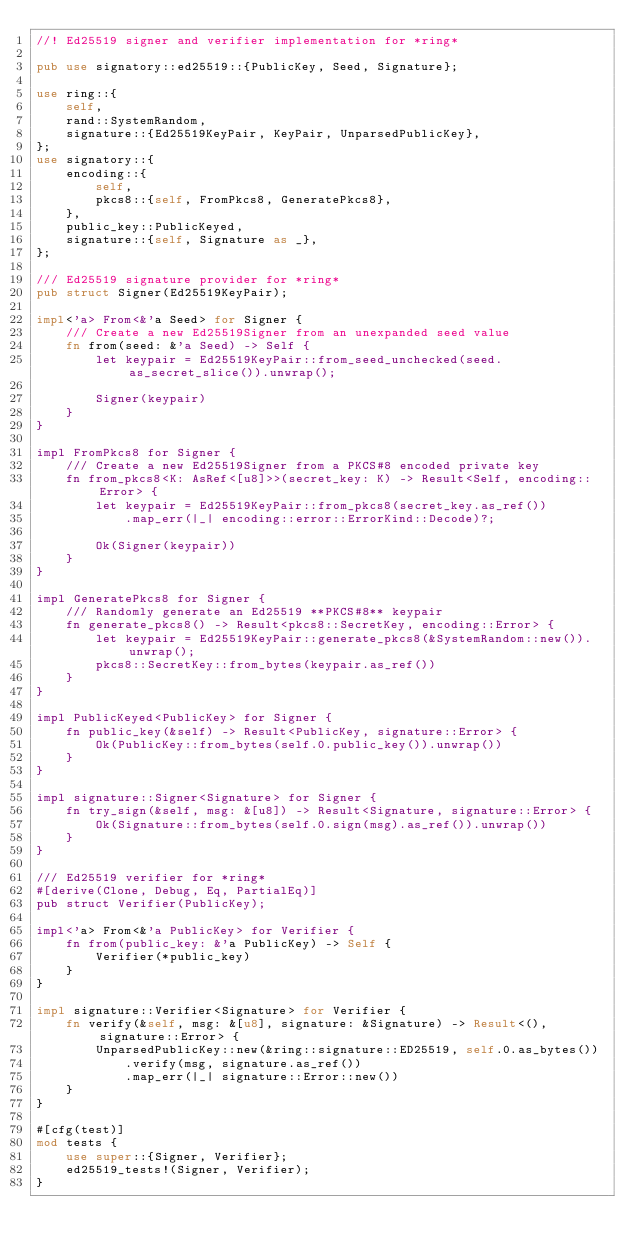<code> <loc_0><loc_0><loc_500><loc_500><_Rust_>//! Ed25519 signer and verifier implementation for *ring*

pub use signatory::ed25519::{PublicKey, Seed, Signature};

use ring::{
    self,
    rand::SystemRandom,
    signature::{Ed25519KeyPair, KeyPair, UnparsedPublicKey},
};
use signatory::{
    encoding::{
        self,
        pkcs8::{self, FromPkcs8, GeneratePkcs8},
    },
    public_key::PublicKeyed,
    signature::{self, Signature as _},
};

/// Ed25519 signature provider for *ring*
pub struct Signer(Ed25519KeyPair);

impl<'a> From<&'a Seed> for Signer {
    /// Create a new Ed25519Signer from an unexpanded seed value
    fn from(seed: &'a Seed) -> Self {
        let keypair = Ed25519KeyPair::from_seed_unchecked(seed.as_secret_slice()).unwrap();

        Signer(keypair)
    }
}

impl FromPkcs8 for Signer {
    /// Create a new Ed25519Signer from a PKCS#8 encoded private key
    fn from_pkcs8<K: AsRef<[u8]>>(secret_key: K) -> Result<Self, encoding::Error> {
        let keypair = Ed25519KeyPair::from_pkcs8(secret_key.as_ref())
            .map_err(|_| encoding::error::ErrorKind::Decode)?;

        Ok(Signer(keypair))
    }
}

impl GeneratePkcs8 for Signer {
    /// Randomly generate an Ed25519 **PKCS#8** keypair
    fn generate_pkcs8() -> Result<pkcs8::SecretKey, encoding::Error> {
        let keypair = Ed25519KeyPair::generate_pkcs8(&SystemRandom::new()).unwrap();
        pkcs8::SecretKey::from_bytes(keypair.as_ref())
    }
}

impl PublicKeyed<PublicKey> for Signer {
    fn public_key(&self) -> Result<PublicKey, signature::Error> {
        Ok(PublicKey::from_bytes(self.0.public_key()).unwrap())
    }
}

impl signature::Signer<Signature> for Signer {
    fn try_sign(&self, msg: &[u8]) -> Result<Signature, signature::Error> {
        Ok(Signature::from_bytes(self.0.sign(msg).as_ref()).unwrap())
    }
}

/// Ed25519 verifier for *ring*
#[derive(Clone, Debug, Eq, PartialEq)]
pub struct Verifier(PublicKey);

impl<'a> From<&'a PublicKey> for Verifier {
    fn from(public_key: &'a PublicKey) -> Self {
        Verifier(*public_key)
    }
}

impl signature::Verifier<Signature> for Verifier {
    fn verify(&self, msg: &[u8], signature: &Signature) -> Result<(), signature::Error> {
        UnparsedPublicKey::new(&ring::signature::ED25519, self.0.as_bytes())
            .verify(msg, signature.as_ref())
            .map_err(|_| signature::Error::new())
    }
}

#[cfg(test)]
mod tests {
    use super::{Signer, Verifier};
    ed25519_tests!(Signer, Verifier);
}
</code> 